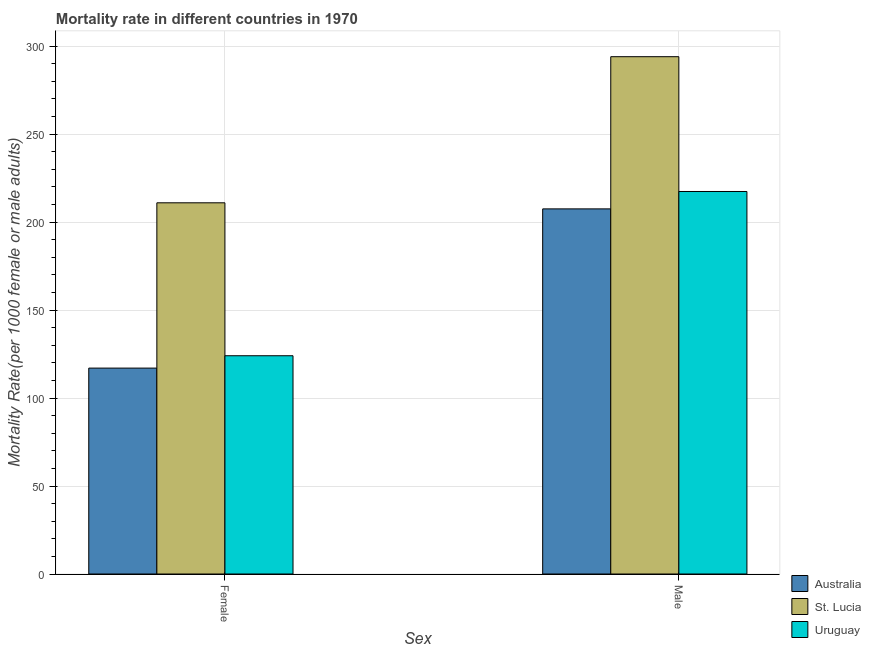How many different coloured bars are there?
Give a very brief answer. 3. How many groups of bars are there?
Your response must be concise. 2. How many bars are there on the 1st tick from the right?
Your response must be concise. 3. What is the male mortality rate in Australia?
Your response must be concise. 207.49. Across all countries, what is the maximum female mortality rate?
Make the answer very short. 210.94. Across all countries, what is the minimum female mortality rate?
Keep it short and to the point. 117. In which country was the female mortality rate maximum?
Keep it short and to the point. St. Lucia. What is the total female mortality rate in the graph?
Your answer should be compact. 451.97. What is the difference between the male mortality rate in St. Lucia and that in Uruguay?
Offer a very short reply. 76.6. What is the difference between the male mortality rate in St. Lucia and the female mortality rate in Australia?
Give a very brief answer. 176.97. What is the average male mortality rate per country?
Give a very brief answer. 239.61. What is the difference between the male mortality rate and female mortality rate in St. Lucia?
Offer a terse response. 83.03. In how many countries, is the female mortality rate greater than 250 ?
Provide a short and direct response. 0. What is the ratio of the female mortality rate in Australia to that in St. Lucia?
Provide a succinct answer. 0.55. Is the male mortality rate in Australia less than that in Uruguay?
Your answer should be compact. Yes. What does the 2nd bar from the left in Male represents?
Provide a succinct answer. St. Lucia. What does the 2nd bar from the right in Female represents?
Provide a succinct answer. St. Lucia. How many bars are there?
Provide a short and direct response. 6. Are all the bars in the graph horizontal?
Keep it short and to the point. No. What is the difference between two consecutive major ticks on the Y-axis?
Your response must be concise. 50. Where does the legend appear in the graph?
Make the answer very short. Bottom right. What is the title of the graph?
Give a very brief answer. Mortality rate in different countries in 1970. What is the label or title of the X-axis?
Provide a short and direct response. Sex. What is the label or title of the Y-axis?
Make the answer very short. Mortality Rate(per 1000 female or male adults). What is the Mortality Rate(per 1000 female or male adults) in Australia in Female?
Offer a terse response. 117. What is the Mortality Rate(per 1000 female or male adults) of St. Lucia in Female?
Ensure brevity in your answer.  210.94. What is the Mortality Rate(per 1000 female or male adults) in Uruguay in Female?
Make the answer very short. 124.03. What is the Mortality Rate(per 1000 female or male adults) in Australia in Male?
Provide a succinct answer. 207.49. What is the Mortality Rate(per 1000 female or male adults) in St. Lucia in Male?
Offer a terse response. 293.97. What is the Mortality Rate(per 1000 female or male adults) in Uruguay in Male?
Offer a terse response. 217.37. Across all Sex, what is the maximum Mortality Rate(per 1000 female or male adults) in Australia?
Your answer should be compact. 207.49. Across all Sex, what is the maximum Mortality Rate(per 1000 female or male adults) in St. Lucia?
Your answer should be compact. 293.97. Across all Sex, what is the maximum Mortality Rate(per 1000 female or male adults) in Uruguay?
Make the answer very short. 217.37. Across all Sex, what is the minimum Mortality Rate(per 1000 female or male adults) of Australia?
Your answer should be compact. 117. Across all Sex, what is the minimum Mortality Rate(per 1000 female or male adults) in St. Lucia?
Offer a terse response. 210.94. Across all Sex, what is the minimum Mortality Rate(per 1000 female or male adults) of Uruguay?
Provide a short and direct response. 124.03. What is the total Mortality Rate(per 1000 female or male adults) of Australia in the graph?
Make the answer very short. 324.49. What is the total Mortality Rate(per 1000 female or male adults) in St. Lucia in the graph?
Your response must be concise. 504.91. What is the total Mortality Rate(per 1000 female or male adults) in Uruguay in the graph?
Make the answer very short. 341.4. What is the difference between the Mortality Rate(per 1000 female or male adults) of Australia in Female and that in Male?
Offer a terse response. -90.48. What is the difference between the Mortality Rate(per 1000 female or male adults) of St. Lucia in Female and that in Male?
Make the answer very short. -83.03. What is the difference between the Mortality Rate(per 1000 female or male adults) of Uruguay in Female and that in Male?
Offer a terse response. -93.34. What is the difference between the Mortality Rate(per 1000 female or male adults) of Australia in Female and the Mortality Rate(per 1000 female or male adults) of St. Lucia in Male?
Your response must be concise. -176.97. What is the difference between the Mortality Rate(per 1000 female or male adults) in Australia in Female and the Mortality Rate(per 1000 female or male adults) in Uruguay in Male?
Make the answer very short. -100.36. What is the difference between the Mortality Rate(per 1000 female or male adults) of St. Lucia in Female and the Mortality Rate(per 1000 female or male adults) of Uruguay in Male?
Offer a terse response. -6.43. What is the average Mortality Rate(per 1000 female or male adults) in Australia per Sex?
Give a very brief answer. 162.24. What is the average Mortality Rate(per 1000 female or male adults) of St. Lucia per Sex?
Your answer should be compact. 252.46. What is the average Mortality Rate(per 1000 female or male adults) in Uruguay per Sex?
Your response must be concise. 170.7. What is the difference between the Mortality Rate(per 1000 female or male adults) of Australia and Mortality Rate(per 1000 female or male adults) of St. Lucia in Female?
Offer a very short reply. -93.94. What is the difference between the Mortality Rate(per 1000 female or male adults) of Australia and Mortality Rate(per 1000 female or male adults) of Uruguay in Female?
Offer a terse response. -7.03. What is the difference between the Mortality Rate(per 1000 female or male adults) in St. Lucia and Mortality Rate(per 1000 female or male adults) in Uruguay in Female?
Provide a succinct answer. 86.91. What is the difference between the Mortality Rate(per 1000 female or male adults) in Australia and Mortality Rate(per 1000 female or male adults) in St. Lucia in Male?
Keep it short and to the point. -86.48. What is the difference between the Mortality Rate(per 1000 female or male adults) of Australia and Mortality Rate(per 1000 female or male adults) of Uruguay in Male?
Offer a terse response. -9.88. What is the difference between the Mortality Rate(per 1000 female or male adults) in St. Lucia and Mortality Rate(per 1000 female or male adults) in Uruguay in Male?
Your answer should be very brief. 76.6. What is the ratio of the Mortality Rate(per 1000 female or male adults) in Australia in Female to that in Male?
Give a very brief answer. 0.56. What is the ratio of the Mortality Rate(per 1000 female or male adults) in St. Lucia in Female to that in Male?
Offer a very short reply. 0.72. What is the ratio of the Mortality Rate(per 1000 female or male adults) in Uruguay in Female to that in Male?
Provide a succinct answer. 0.57. What is the difference between the highest and the second highest Mortality Rate(per 1000 female or male adults) of Australia?
Make the answer very short. 90.48. What is the difference between the highest and the second highest Mortality Rate(per 1000 female or male adults) in St. Lucia?
Provide a short and direct response. 83.03. What is the difference between the highest and the second highest Mortality Rate(per 1000 female or male adults) of Uruguay?
Your answer should be very brief. 93.34. What is the difference between the highest and the lowest Mortality Rate(per 1000 female or male adults) of Australia?
Your answer should be very brief. 90.48. What is the difference between the highest and the lowest Mortality Rate(per 1000 female or male adults) of St. Lucia?
Give a very brief answer. 83.03. What is the difference between the highest and the lowest Mortality Rate(per 1000 female or male adults) in Uruguay?
Ensure brevity in your answer.  93.34. 